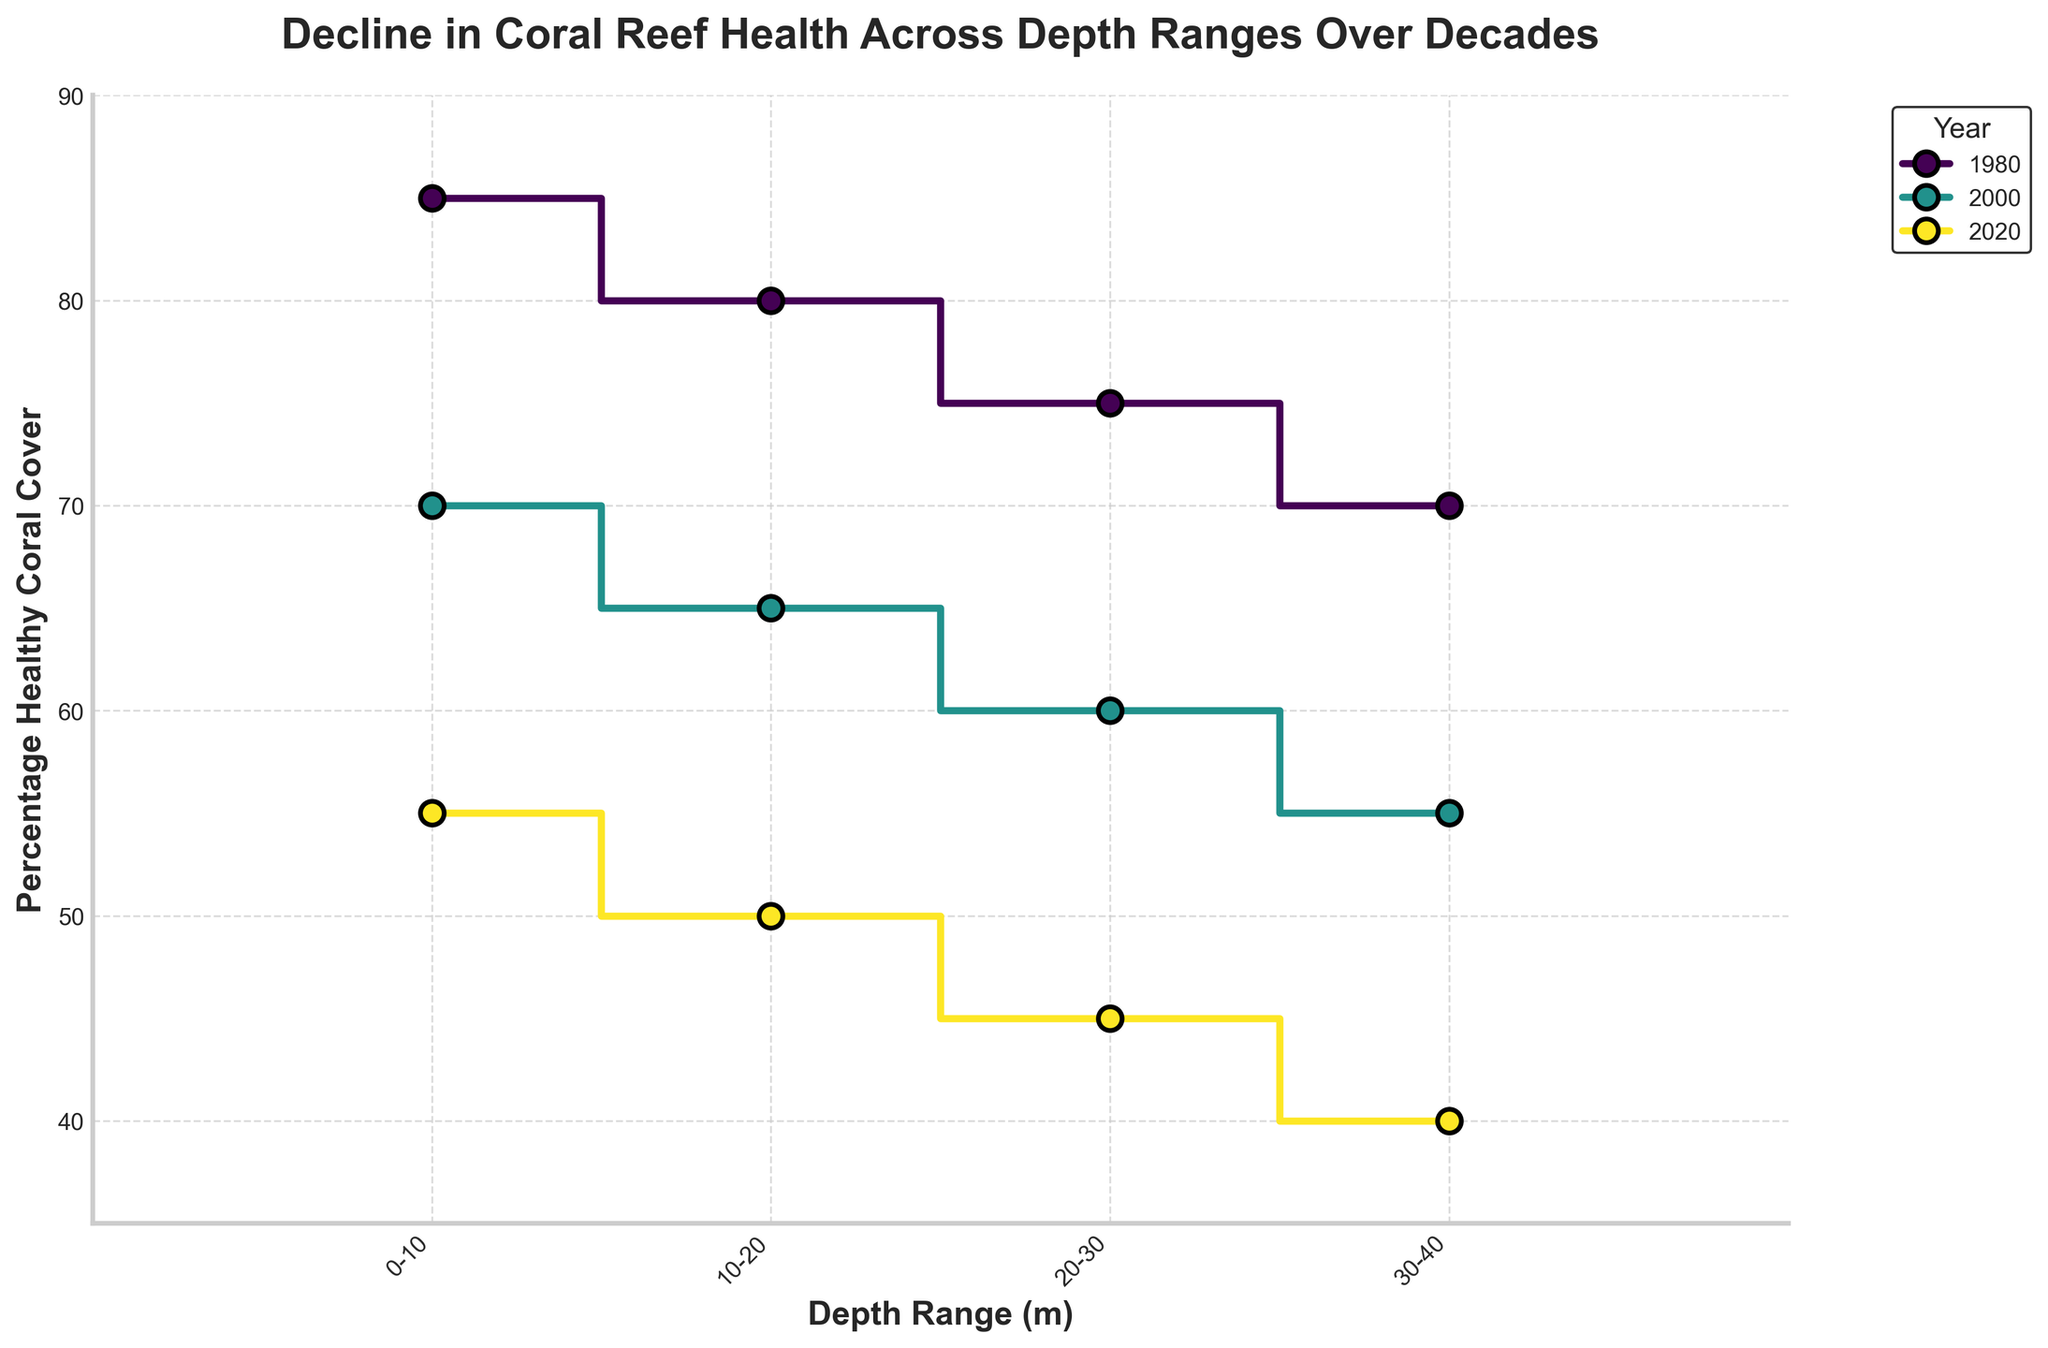What's the title of the figure? The title is usually located at the top of the plot and summarizes the main idea presented in the figure. In this case, the title is "Decline in Coral Reef Health Across Depth Ranges Over Decades".
Answer: Decline in Coral Reef Health Across Depth Ranges Over Decades How many years are represented in the plot? By examining the legend on the plot, we see that there are three colors, each corresponding to a different year.
Answer: 3 What are the depth ranges shown on the x-axis? The x-axis labels provide depth ranges, which are visible as text on the horizontal line at the bottom of the plot. These are "0-10", "10-20", "20-30", "30-40" meters.
Answer: 0-10, 10-20, 20-30, 30-40 What is the y-axis label and its range? The y-axis label indicates what is being measured, which in this case is the "Percentage Healthy Coral Cover". The range of the y-axis can be determined by looking at the lowest and highest values on the vertical line to the left of the plot. It ranges from 35% to 90%.
Answer: Percentage Healthy Coral Cover; 35% to 90% In which year was the percentage of healthy coral cover highest in the 0-10 meter depth range? By following the data points corresponding to the 0-10 meter depth range for each year, we see that the highest percentage is at 85% in the year 1980.
Answer: 1980 What is the overall trend in coral health from 1980 to 2020? Observing the plotted lines from left to right, each depth range shows a consistent decline in the percentage of healthy coral from 1980 to 2020.
Answer: Decline What is the difference in healthy coral cover between the 0-10 meter depth range in 1980 and 2020? The percentage of healthy coral cover in the 0-10 meter range was 85% in 1980 and 55% in 2020. Subtracting these values gives the difference: 85% - 55% = 30%.
Answer: 30% Which depth range shows the smallest decline in coral health from 1980 to 2020? By analyzing the decline across all depth ranges, we note the differences: 
- 0-10m: 85 - 55 = 30%
- 10-20m: 80 - 50 = 30%
- 20-30m: 75 - 45 = 30%
- 30-40m: 70 - 40 = 30%
Each depth range shows an equal decline of 30%, so no single range has the smallest decline individually.
Answer: All ranges have equal decline How does the percentage of healthy coral cover in 2000 compare between the 10-20 meter and 30-40 meter depth ranges? By looking at the specific markers for the year 2000, the percentage for the 10-20 meter range is 65% and for the 30-40 meter range it is 55%. Comparing these two values directly shows that the cover is higher in the 10-20 meter depth range.
Answer: 10-20 meter range is higher Which year shows the greatest variability in coral health across all depth ranges? To determine which year has the greatest variability, observe the range of values for each year:
- 1980: (85 - 70) = 15%
- 2000: (70 - 55) = 15%
- 2020: (55 - 40) = 15%
Each year shows the same range of variability in coral health cover.
Answer: All years have the same variability 